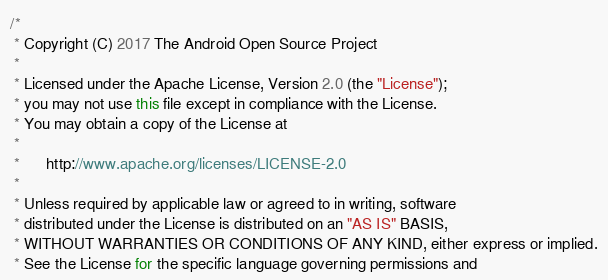Convert code to text. <code><loc_0><loc_0><loc_500><loc_500><_Java_>/*
 * Copyright (C) 2017 The Android Open Source Project
 *
 * Licensed under the Apache License, Version 2.0 (the "License");
 * you may not use this file except in compliance with the License.
 * You may obtain a copy of the License at
 *
 *      http://www.apache.org/licenses/LICENSE-2.0
 *
 * Unless required by applicable law or agreed to in writing, software
 * distributed under the License is distributed on an "AS IS" BASIS,
 * WITHOUT WARRANTIES OR CONDITIONS OF ANY KIND, either express or implied.
 * See the License for the specific language governing permissions and</code> 